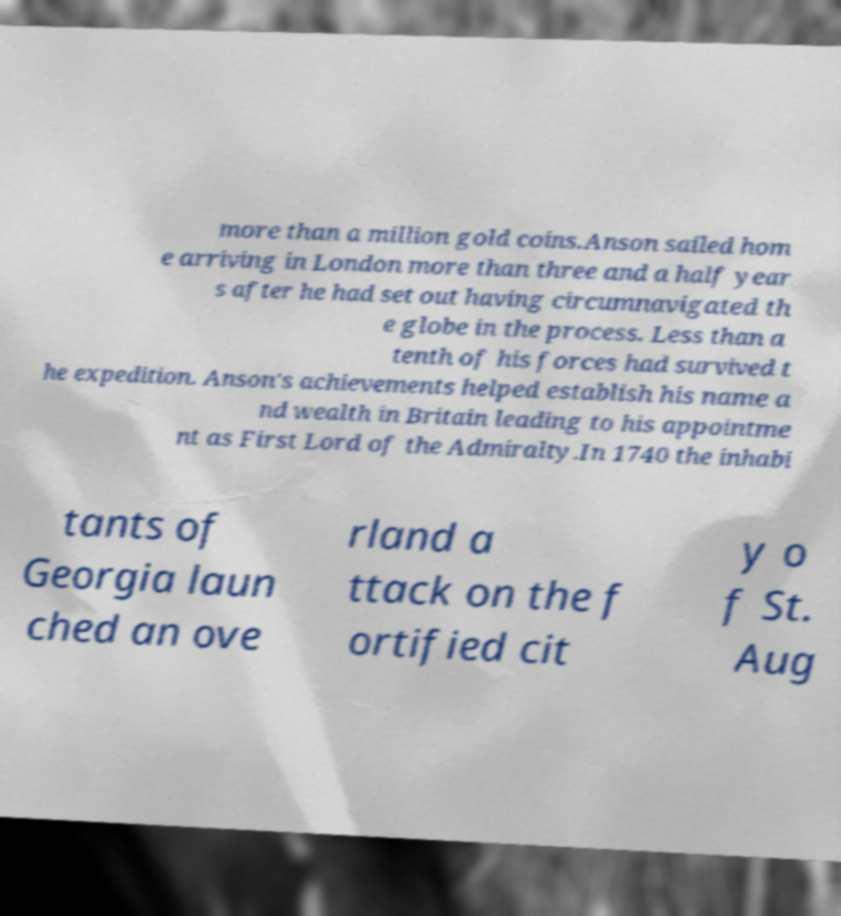Could you assist in decoding the text presented in this image and type it out clearly? more than a million gold coins.Anson sailed hom e arriving in London more than three and a half year s after he had set out having circumnavigated th e globe in the process. Less than a tenth of his forces had survived t he expedition. Anson's achievements helped establish his name a nd wealth in Britain leading to his appointme nt as First Lord of the Admiralty.In 1740 the inhabi tants of Georgia laun ched an ove rland a ttack on the f ortified cit y o f St. Aug 